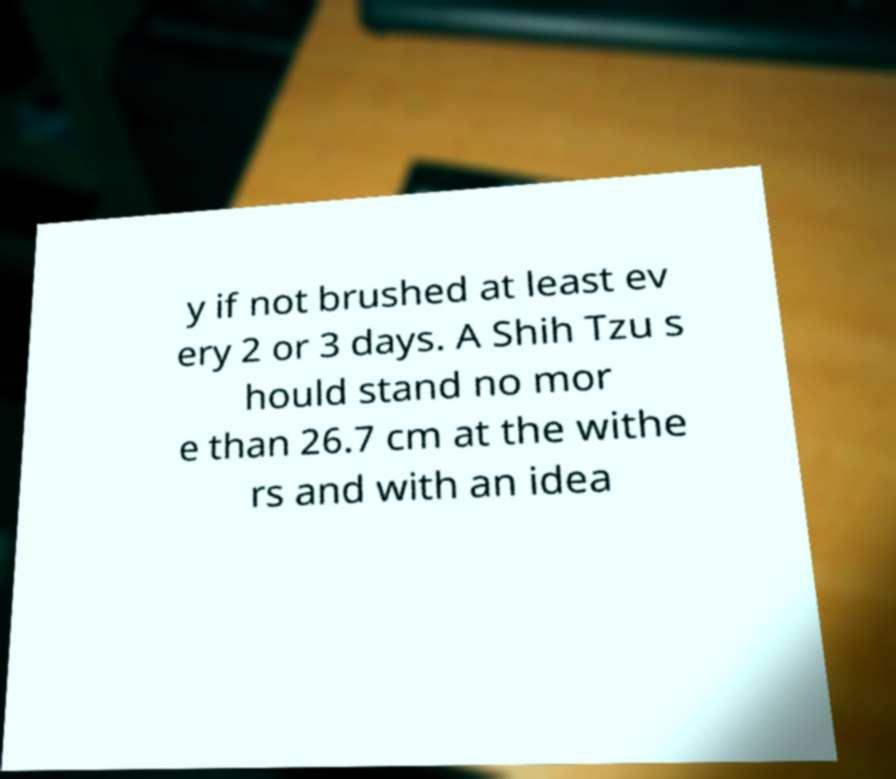Can you accurately transcribe the text from the provided image for me? y if not brushed at least ev ery 2 or 3 days. A Shih Tzu s hould stand no mor e than 26.7 cm at the withe rs and with an idea 